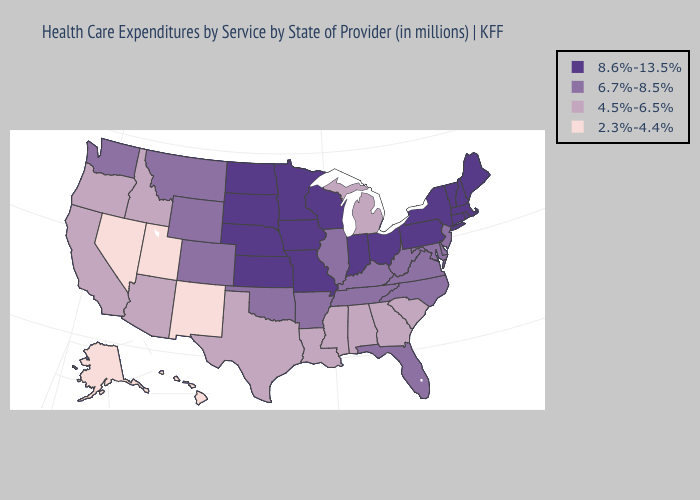Among the states that border New York , which have the lowest value?
Give a very brief answer. New Jersey. Does Louisiana have a higher value than Nevada?
Concise answer only. Yes. What is the highest value in the USA?
Short answer required. 8.6%-13.5%. Among the states that border Texas , does Arkansas have the highest value?
Give a very brief answer. Yes. What is the highest value in the USA?
Quick response, please. 8.6%-13.5%. What is the lowest value in states that border New York?
Answer briefly. 6.7%-8.5%. How many symbols are there in the legend?
Write a very short answer. 4. Does South Carolina have the lowest value in the USA?
Keep it brief. No. How many symbols are there in the legend?
Answer briefly. 4. Name the states that have a value in the range 2.3%-4.4%?
Keep it brief. Alaska, Hawaii, Nevada, New Mexico, Utah. What is the value of Wisconsin?
Be succinct. 8.6%-13.5%. Does the first symbol in the legend represent the smallest category?
Be succinct. No. Name the states that have a value in the range 6.7%-8.5%?
Be succinct. Arkansas, Colorado, Delaware, Florida, Illinois, Kentucky, Maryland, Montana, New Jersey, North Carolina, Oklahoma, Tennessee, Virginia, Washington, West Virginia, Wyoming. Among the states that border New York , which have the highest value?
Be succinct. Connecticut, Massachusetts, Pennsylvania, Vermont. 